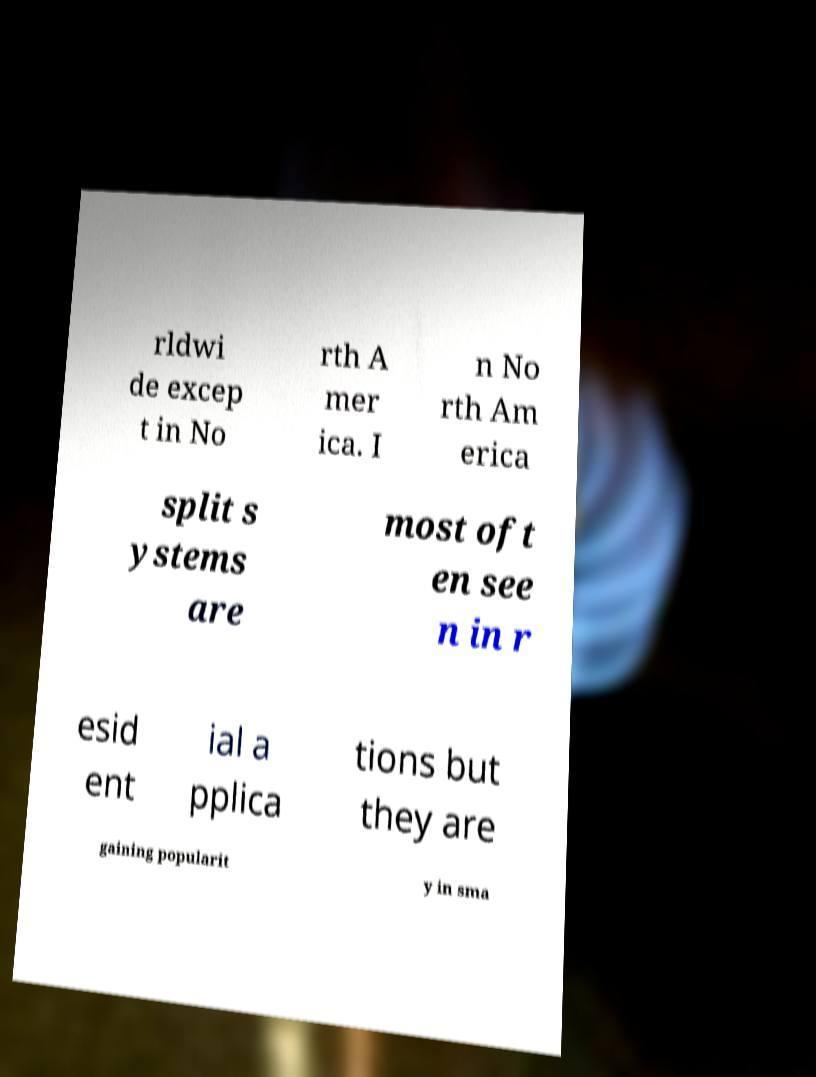I need the written content from this picture converted into text. Can you do that? rldwi de excep t in No rth A mer ica. I n No rth Am erica split s ystems are most oft en see n in r esid ent ial a pplica tions but they are gaining popularit y in sma 